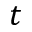Convert formula to latex. <formula><loc_0><loc_0><loc_500><loc_500>t</formula> 